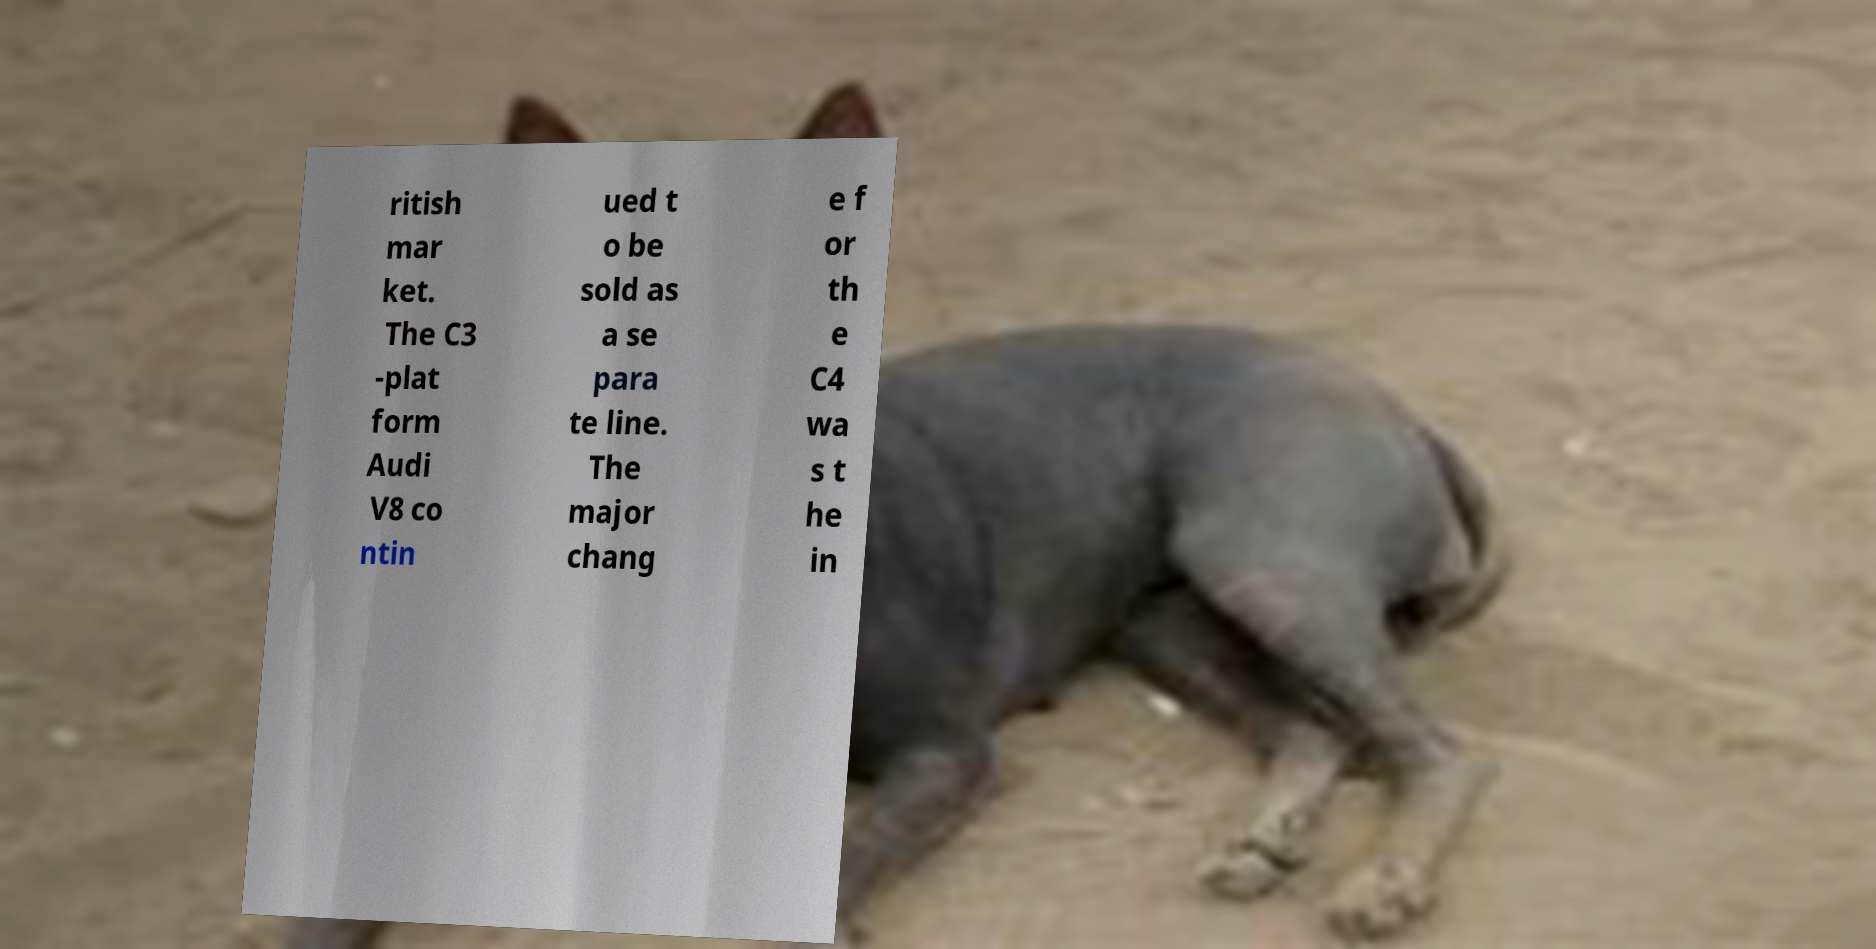I need the written content from this picture converted into text. Can you do that? ritish mar ket. The C3 -plat form Audi V8 co ntin ued t o be sold as a se para te line. The major chang e f or th e C4 wa s t he in 